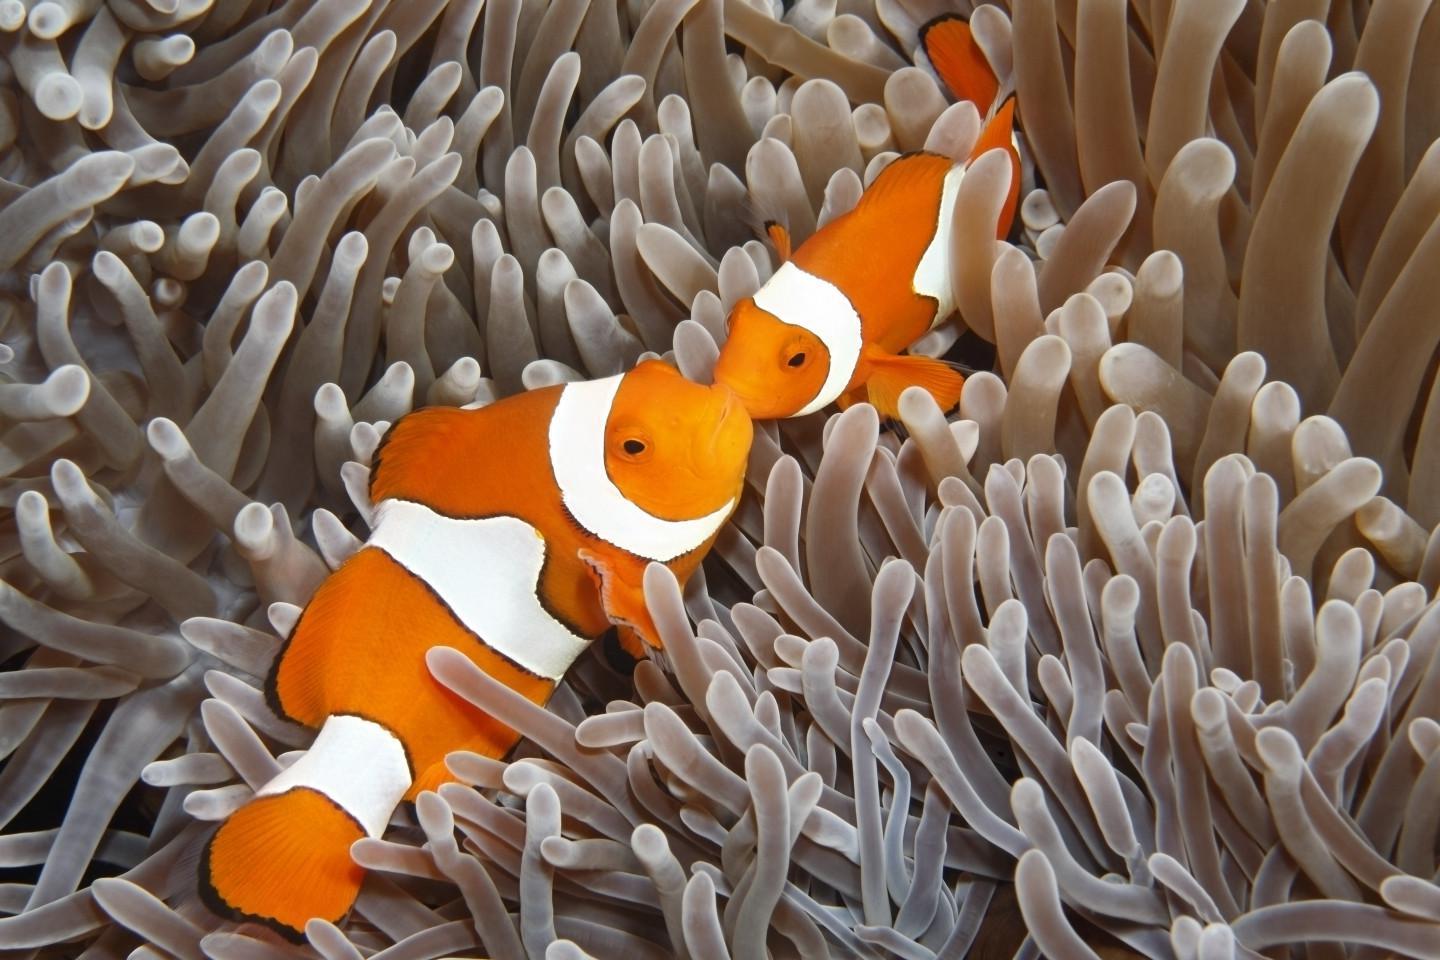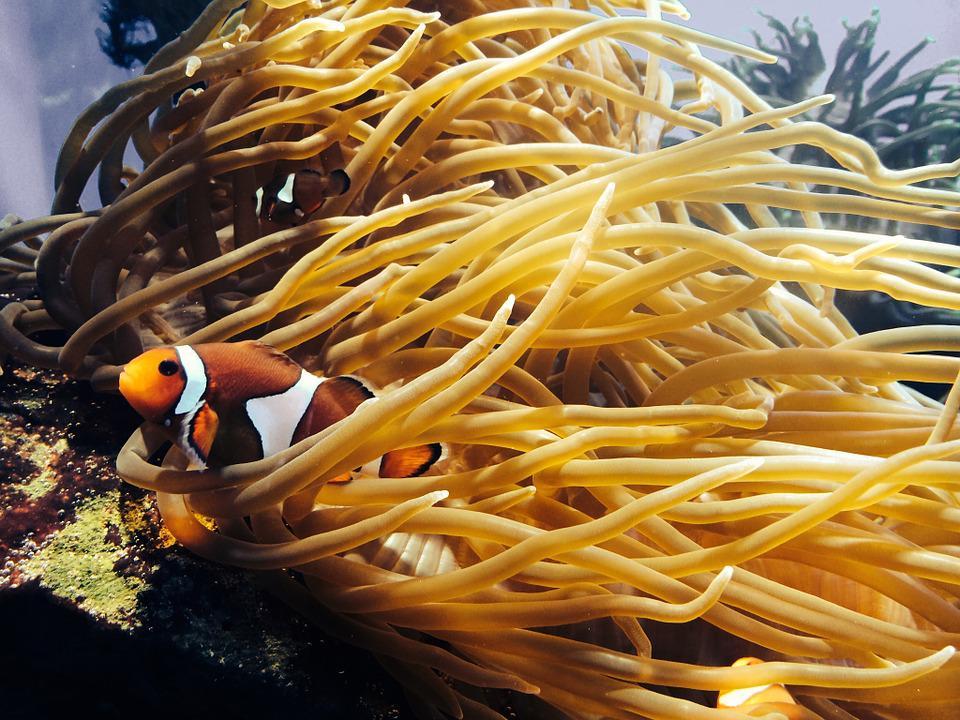The first image is the image on the left, the second image is the image on the right. For the images shown, is this caption "In at least one image there is a single white clownfish with white, black and orange colors swimming through  the arms of corral." true? Answer yes or no. Yes. The first image is the image on the left, the second image is the image on the right. Evaluate the accuracy of this statement regarding the images: "Each image features no more than two orange fish in the foreground, and the fish in the left and right images are posed among anemone tendrils of the same color.". Is it true? Answer yes or no. No. 